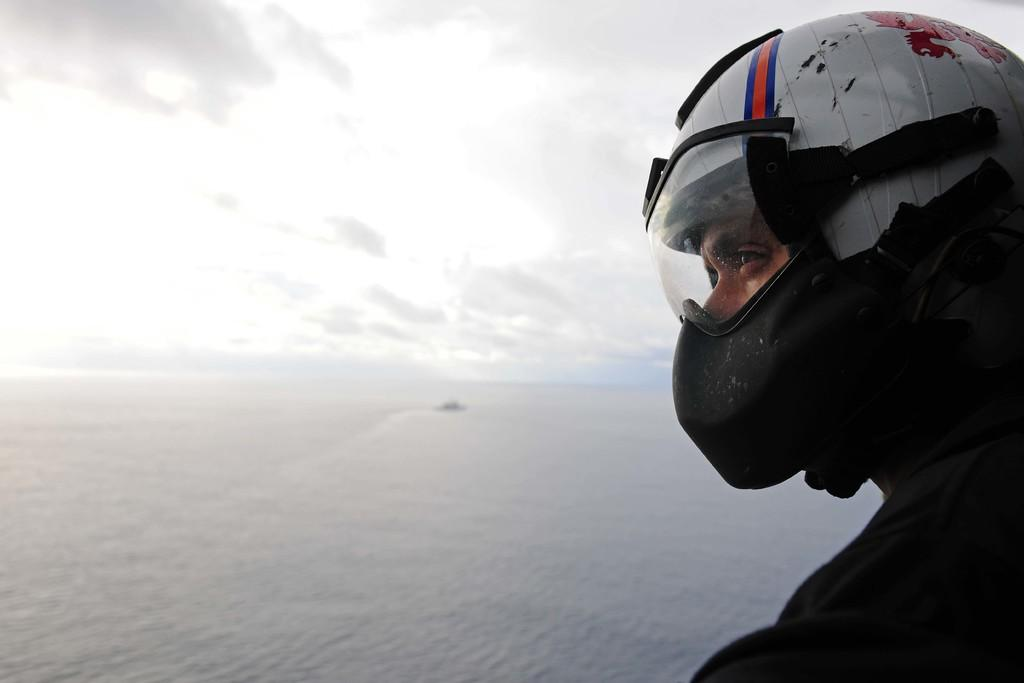Who is present in the image? There is a man in the image. What is the man wearing on his head? The man is wearing a helmet. What can be seen in large quantities in the image? There is a large amount of water visible in the image. What is visible in the sky in the image? Clouds are present in the sky. What type of plot is the man digging with a spade in the image? There is no spade or digging activity present in the image. 